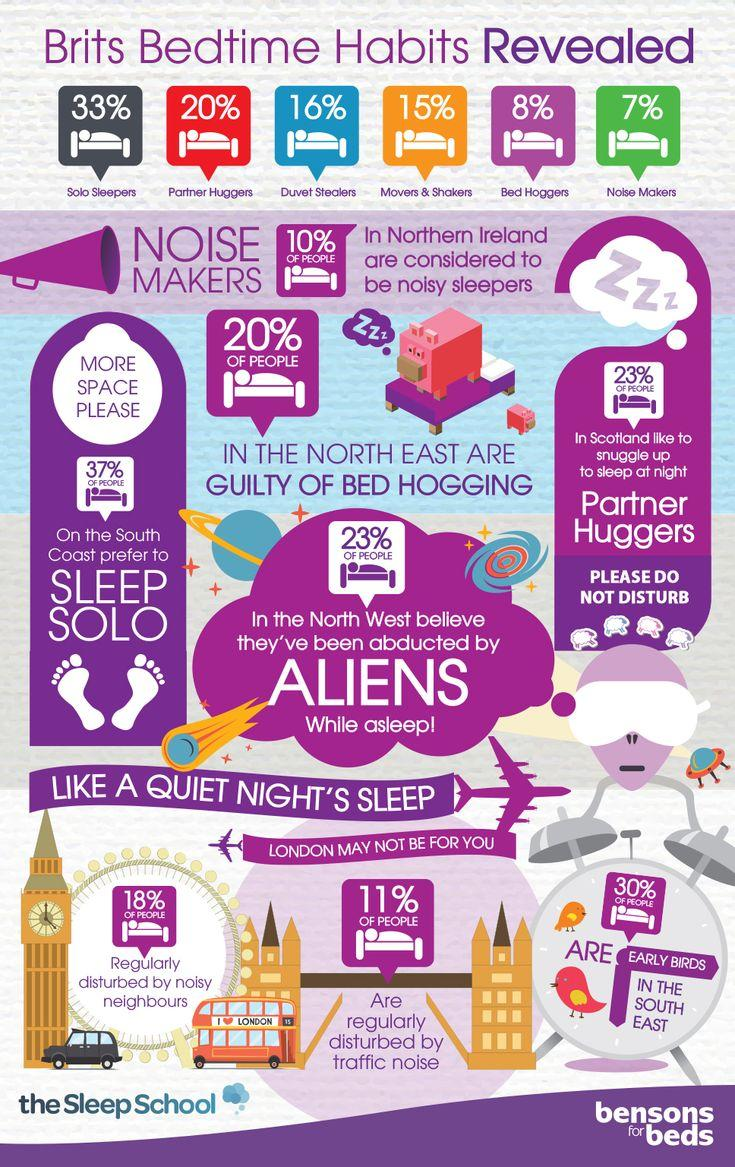List a handful of essential elements in this visual. A recent survey conducted in London has revealed that approximately 11% of the population is regularly disturbed by traffic noise. In the south east of London, approximately 30% of people are considered early birds. In London, 18% of individuals are frequently disturbed by noisy neighbors, according to a recent survey. A shocking 20% of individuals in the north east region have been found to be guilty of bed hogging, a behavior that is not only inconsiderate but also negatively impacts the comfort and well-being of their fellow passengers. A recent study has found that approximately 10% of the population in Northern Ireland are considered to be noisy sleepers. 